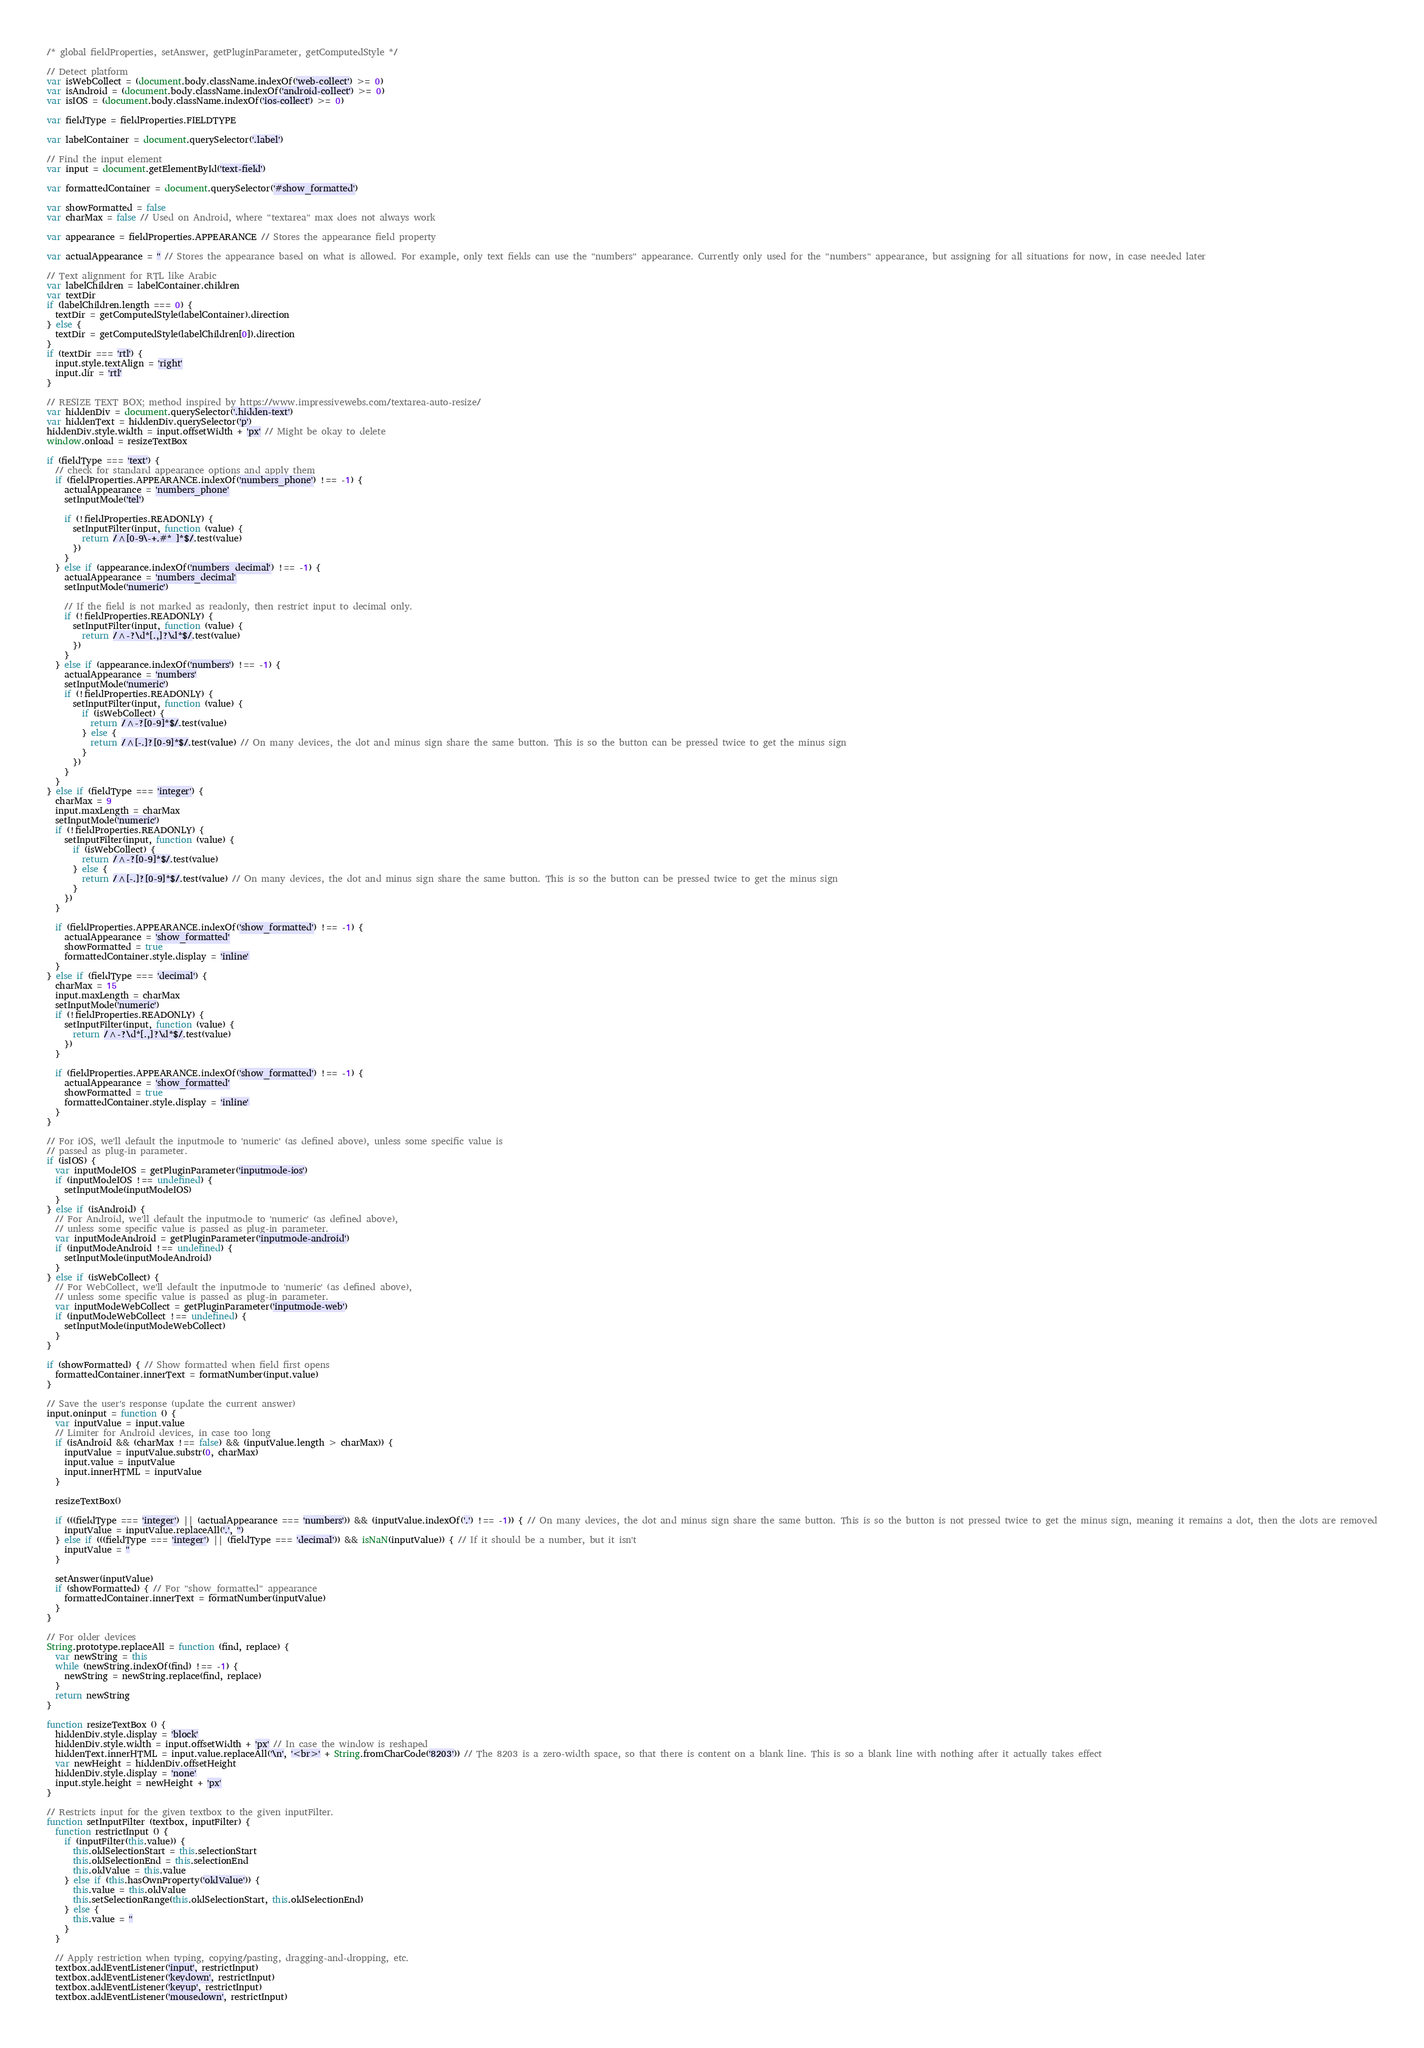<code> <loc_0><loc_0><loc_500><loc_500><_JavaScript_>/* global fieldProperties, setAnswer, getPluginParameter, getComputedStyle */

// Detect platform
var isWebCollect = (document.body.className.indexOf('web-collect') >= 0)
var isAndroid = (document.body.className.indexOf('android-collect') >= 0)
var isIOS = (document.body.className.indexOf('ios-collect') >= 0)

var fieldType = fieldProperties.FIELDTYPE

var labelContainer = document.querySelector('.label')

// Find the input element
var input = document.getElementById('text-field')

var formattedContainer = document.querySelector('#show_formatted')

var showFormatted = false
var charMax = false // Used on Android, where "textarea" max does not always work

var appearance = fieldProperties.APPEARANCE // Stores the appearance field property

var actualAppearance = '' // Stores the appearance based on what is allowed. For example, only text fields can use the "numbers" appearance. Currently only used for the "numbers" appearance, but assigning for all situations for now, in case needed later

// Text alignment for RTL like Arabic
var labelChildren = labelContainer.children
var textDir
if (labelChildren.length === 0) {
  textDir = getComputedStyle(labelContainer).direction
} else {
  textDir = getComputedStyle(labelChildren[0]).direction
}
if (textDir === 'rtl') {
  input.style.textAlign = 'right'
  input.dir = 'rtl'
}

// RESIZE TEXT BOX; method inspired by https://www.impressivewebs.com/textarea-auto-resize/
var hiddenDiv = document.querySelector('.hidden-text')
var hiddenText = hiddenDiv.querySelector('p')
hiddenDiv.style.width = input.offsetWidth + 'px' // Might be okay to delete
window.onload = resizeTextBox

if (fieldType === 'text') {
  // check for standard appearance options and apply them
  if (fieldProperties.APPEARANCE.indexOf('numbers_phone') !== -1) {
    actualAppearance = 'numbers_phone'
    setInputMode('tel')

    if (!fieldProperties.READONLY) {
      setInputFilter(input, function (value) {
        return /^[0-9\-+.#* ]*$/.test(value)
      })
    }
  } else if (appearance.indexOf('numbers_decimal') !== -1) {
    actualAppearance = 'numbers_decimal'
    setInputMode('numeric')

    // If the field is not marked as readonly, then restrict input to decimal only.
    if (!fieldProperties.READONLY) {
      setInputFilter(input, function (value) {
        return /^-?\d*[.,]?\d*$/.test(value)
      })
    }
  } else if (appearance.indexOf('numbers') !== -1) {
    actualAppearance = 'numbers'
    setInputMode('numeric')
    if (!fieldProperties.READONLY) {
      setInputFilter(input, function (value) {
        if (isWebCollect) {
          return /^-?[0-9]*$/.test(value)
        } else {
          return /^[-.]?[0-9]*$/.test(value) // On many devices, the dot and minus sign share the same button. This is so the button can be pressed twice to get the minus sign
        }
      })
    }
  }
} else if (fieldType === 'integer') {
  charMax = 9
  input.maxLength = charMax
  setInputMode('numeric')
  if (!fieldProperties.READONLY) {
    setInputFilter(input, function (value) {
      if (isWebCollect) {
        return /^-?[0-9]*$/.test(value)
      } else {
        return /^[-.]?[0-9]*$/.test(value) // On many devices, the dot and minus sign share the same button. This is so the button can be pressed twice to get the minus sign
      }
    })
  }

  if (fieldProperties.APPEARANCE.indexOf('show_formatted') !== -1) {
    actualAppearance = 'show_formatted'
    showFormatted = true
    formattedContainer.style.display = 'inline'
  }
} else if (fieldType === 'decimal') {
  charMax = 15
  input.maxLength = charMax
  setInputMode('numeric')
  if (!fieldProperties.READONLY) {
    setInputFilter(input, function (value) {
      return /^-?\d*[.,]?\d*$/.test(value)
    })
  }

  if (fieldProperties.APPEARANCE.indexOf('show_formatted') !== -1) {
    actualAppearance = 'show_formatted'
    showFormatted = true
    formattedContainer.style.display = 'inline'
  }
}

// For iOS, we'll default the inputmode to 'numeric' (as defined above), unless some specific value is
// passed as plug-in parameter.
if (isIOS) {
  var inputModeIOS = getPluginParameter('inputmode-ios')
  if (inputModeIOS !== undefined) {
    setInputMode(inputModeIOS)
  }
} else if (isAndroid) {
  // For Android, we'll default the inputmode to 'numeric' (as defined above),
  // unless some specific value is passed as plug-in parameter.
  var inputModeAndroid = getPluginParameter('inputmode-android')
  if (inputModeAndroid !== undefined) {
    setInputMode(inputModeAndroid)
  }
} else if (isWebCollect) {
  // For WebCollect, we'll default the inputmode to 'numeric' (as defined above),
  // unless some specific value is passed as plug-in parameter.
  var inputModeWebCollect = getPluginParameter('inputmode-web')
  if (inputModeWebCollect !== undefined) {
    setInputMode(inputModeWebCollect)
  }
}

if (showFormatted) { // Show formatted when field first opens
  formattedContainer.innerText = formatNumber(input.value)
}

// Save the user's response (update the current answer)
input.oninput = function () {
  var inputValue = input.value
  // Limiter for Android devices, in case too long
  if (isAndroid && (charMax !== false) && (inputValue.length > charMax)) {
    inputValue = inputValue.substr(0, charMax)
    input.value = inputValue
    input.innerHTML = inputValue
  }

  resizeTextBox()

  if (((fieldType === 'integer') || (actualAppearance === 'numbers')) && (inputValue.indexOf('.') !== -1)) { // On many devices, the dot and minus sign share the same button. This is so the button is not pressed twice to get the minus sign, meaning it remains a dot, then the dots are removed
    inputValue = inputValue.replaceAll('.', '')
  } else if (((fieldType === 'integer') || (fieldType === 'decimal')) && isNaN(inputValue)) { // If it should be a number, but it isn't
    inputValue = ''
  }

  setAnswer(inputValue)
  if (showFormatted) { // For "show_formatted" appearance
    formattedContainer.innerText = formatNumber(inputValue)
  }
}

// For older devices
String.prototype.replaceAll = function (find, replace) {
  var newString = this
  while (newString.indexOf(find) !== -1) {
    newString = newString.replace(find, replace)
  }
  return newString
}

function resizeTextBox () {
  hiddenDiv.style.display = 'block'
  hiddenDiv.style.width = input.offsetWidth + 'px' // In case the window is reshaped
  hiddenText.innerHTML = input.value.replaceAll('\n', '<br>' + String.fromCharCode('8203')) // The 8203 is a zero-width space, so that there is content on a blank line. This is so a blank line with nothing after it actually takes effect
  var newHeight = hiddenDiv.offsetHeight
  hiddenDiv.style.display = 'none'
  input.style.height = newHeight + 'px'
}

// Restricts input for the given textbox to the given inputFilter.
function setInputFilter (textbox, inputFilter) {
  function restrictInput () {
    if (inputFilter(this.value)) {
      this.oldSelectionStart = this.selectionStart
      this.oldSelectionEnd = this.selectionEnd
      this.oldValue = this.value
    } else if (this.hasOwnProperty('oldValue')) {
      this.value = this.oldValue
      this.setSelectionRange(this.oldSelectionStart, this.oldSelectionEnd)
    } else {
      this.value = ''
    }
  }

  // Apply restriction when typing, copying/pasting, dragging-and-dropping, etc.
  textbox.addEventListener('input', restrictInput)
  textbox.addEventListener('keydown', restrictInput)
  textbox.addEventListener('keyup', restrictInput)
  textbox.addEventListener('mousedown', restrictInput)</code> 